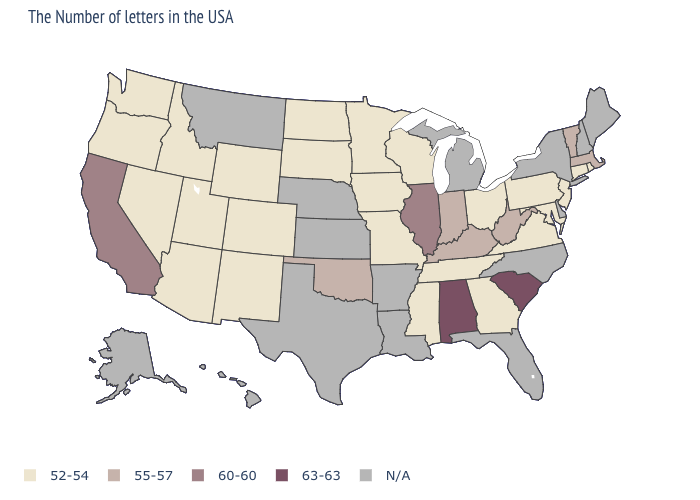Name the states that have a value in the range N/A?
Concise answer only. Maine, New Hampshire, New York, Delaware, North Carolina, Florida, Michigan, Louisiana, Arkansas, Kansas, Nebraska, Texas, Montana, Alaska, Hawaii. Does the first symbol in the legend represent the smallest category?
Short answer required. Yes. Is the legend a continuous bar?
Short answer required. No. What is the value of Oklahoma?
Quick response, please. 55-57. What is the value of Virginia?
Short answer required. 52-54. Name the states that have a value in the range 63-63?
Answer briefly. South Carolina, Alabama. What is the value of Louisiana?
Short answer required. N/A. Does Missouri have the highest value in the MidWest?
Short answer required. No. What is the value of Kansas?
Answer briefly. N/A. Does Virginia have the lowest value in the USA?
Short answer required. Yes. Name the states that have a value in the range 63-63?
Keep it brief. South Carolina, Alabama. Name the states that have a value in the range 52-54?
Answer briefly. Rhode Island, Connecticut, New Jersey, Maryland, Pennsylvania, Virginia, Ohio, Georgia, Tennessee, Wisconsin, Mississippi, Missouri, Minnesota, Iowa, South Dakota, North Dakota, Wyoming, Colorado, New Mexico, Utah, Arizona, Idaho, Nevada, Washington, Oregon. Which states hav the highest value in the MidWest?
Answer briefly. Illinois. Does Oklahoma have the lowest value in the South?
Short answer required. No. What is the value of Utah?
Keep it brief. 52-54. 